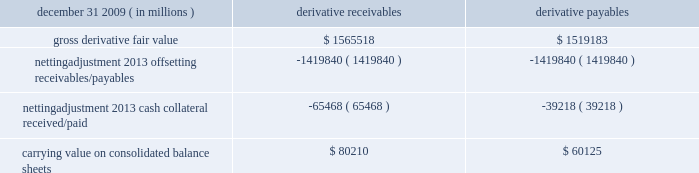Jpmorgan chase & co./2009 annual report 181 the table shows the current credit risk of derivative receivables after netting adjustments , and the current liquidity risk of derivative payables after netting adjustments , as of december 31 , 2009. .
In addition to the collateral amounts reflected in the table above , at december 31 , 2009 , the firm had received and posted liquid secu- rities collateral in the amount of $ 15.5 billion and $ 11.7 billion , respectively .
The firm also receives and delivers collateral at the initiation of derivative transactions , which is available as security against potential exposure that could arise should the fair value of the transactions move in the firm 2019s or client 2019s favor , respectively .
Furthermore , the firm and its counterparties hold collateral related to contracts that have a non-daily call frequency for collateral to be posted , and collateral that the firm or a counterparty has agreed to return but has not yet settled as of the reporting date .
At december 31 , 2009 , the firm had received $ 16.9 billion and delivered $ 5.8 billion of such additional collateral .
These amounts were not netted against the derivative receivables and payables in the table above , because , at an individual counterparty level , the collateral exceeded the fair value exposure at december 31 , 2009 .
Credit derivatives credit derivatives are financial instruments whose value is derived from the credit risk associated with the debt of a third-party issuer ( the reference entity ) and which allow one party ( the protection purchaser ) to transfer that risk to another party ( the protection seller ) .
Credit derivatives expose the protection purchaser to the creditworthiness of the protection seller , as the protection seller is required to make payments under the contract when the reference entity experiences a credit event , such as a bankruptcy , a failure to pay its obligation or a restructuring .
The seller of credit protection receives a premium for providing protection but has the risk that the underlying instrument referenced in the contract will be subject to a credit event .
The firm is both a purchaser and seller of protection in the credit derivatives market and uses these derivatives for two primary purposes .
First , in its capacity as a market-maker in the dealer/client business , the firm actively risk manages a portfolio of credit derivatives by purchasing and selling credit protection , pre- dominantly on corporate debt obligations , to meet the needs of customers .
As a seller of protection , the firm 2019s exposure to a given reference entity may be offset partially , or entirely , with a contract to purchase protection from another counterparty on the same or similar reference entity .
Second , the firm uses credit derivatives to mitigate credit risk associated with its overall derivative receivables and traditional commercial credit lending exposures ( loans and unfunded commitments ) as well as to manage its exposure to residential and commercial mortgages .
See note 3 on pages 156--- 173 of this annual report for further information on the firm 2019s mortgage-related exposures .
In accomplishing the above , the firm uses different types of credit derivatives .
Following is a summary of various types of credit derivatives .
Credit default swaps credit derivatives may reference the credit of either a single refer- ence entity ( 201csingle-name 201d ) or a broad-based index , as described further below .
The firm purchases and sells protection on both single- name and index-reference obligations .
Single-name cds and index cds contracts are both otc derivative contracts .
Single- name cds are used to manage the default risk of a single reference entity , while cds index are used to manage credit risk associated with the broader credit markets or credit market segments .
Like the s&p 500 and other market indices , a cds index is comprised of a portfolio of cds across many reference entities .
New series of cds indices are established approximately every six months with a new underlying portfolio of reference entities to reflect changes in the credit markets .
If one of the reference entities in the index experi- ences a credit event , then the reference entity that defaulted is removed from the index .
Cds can also be referenced against spe- cific portfolios of reference names or against customized exposure levels based on specific client demands : for example , to provide protection against the first $ 1 million of realized credit losses in a $ 10 million portfolio of exposure .
Such structures are commonly known as tranche cds .
For both single-name cds contracts and index cds , upon the occurrence of a credit event , under the terms of a cds contract neither party to the cds contract has recourse to the reference entity .
The protection purchaser has recourse to the protection seller for the difference between the face value of the cds contract and the fair value of the reference obligation at the time of settling the credit derivative contract , also known as the recovery value .
The protection purchaser does not need to hold the debt instrument of the underlying reference entity in order to receive amounts due under the cds contract when a credit event occurs .
Credit-linked notes a credit linked note ( 201ccln 201d ) is a funded credit derivative where the issuer of the cln purchases credit protection on a referenced entity from the note investor .
Under the contract , the investor pays the issuer par value of the note at the inception of the transaction , and in return , the issuer pays periodic payments to the investor , based on the credit risk of the referenced entity .
The issuer also repays the investor the par value of the note at maturity unless the reference entity experiences a specified credit event .
In that event , the issuer is not obligated to repay the par value of the note , but rather , the issuer pays the investor the difference between the par value of the note .
What was the net fair value of derivatives , in millions? 
Computations: (1565518 - 1519183)
Answer: 46335.0. 